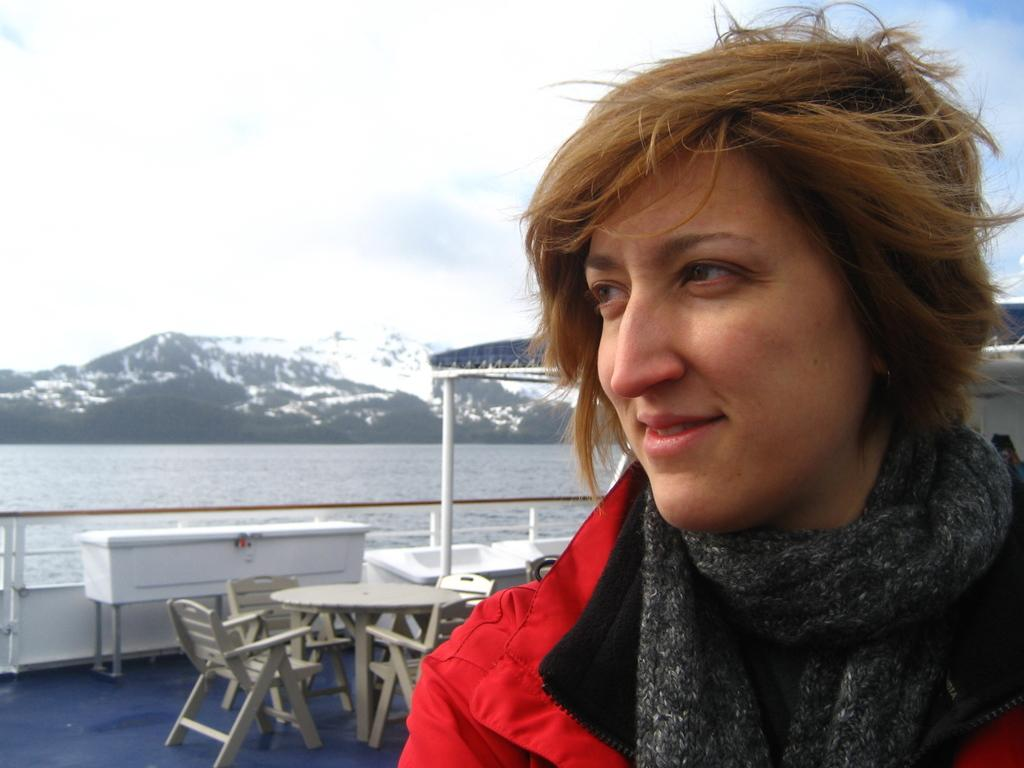Who is present in the image? There is a person in the image. What is the person's expression? The person is smiling. Where is the person located? The person is inside a ship. What furniture can be seen inside the ship? There is a dining table and a cupboard inside the ship. What can be seen in the background of the image? Water, mountains, and the sky are visible in the background of the image. Where is the hydrant located in the image? There is no hydrant present in the image. What type of scarecrow can be seen standing near the mountains in the background? There is no scarecrow present in the image; only the person, ship, and background elements are visible. 